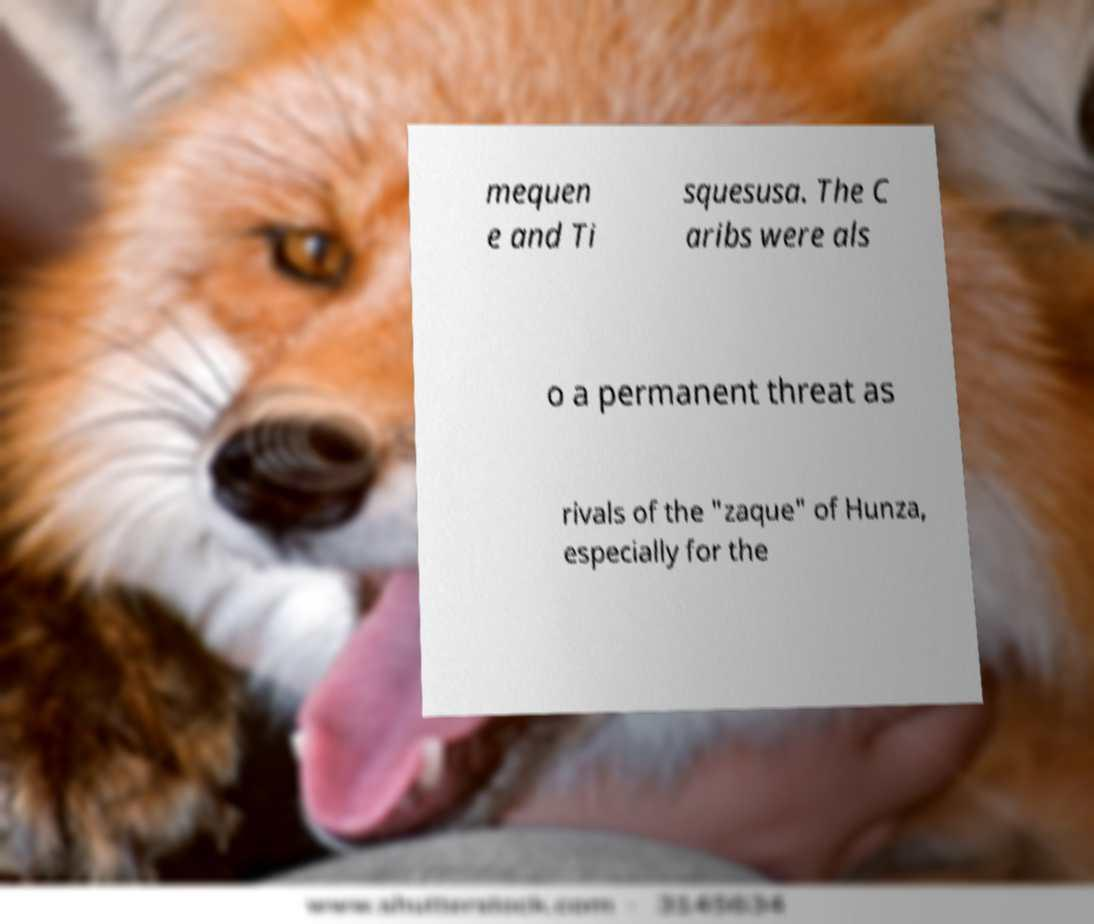I need the written content from this picture converted into text. Can you do that? mequen e and Ti squesusa. The C aribs were als o a permanent threat as rivals of the "zaque" of Hunza, especially for the 